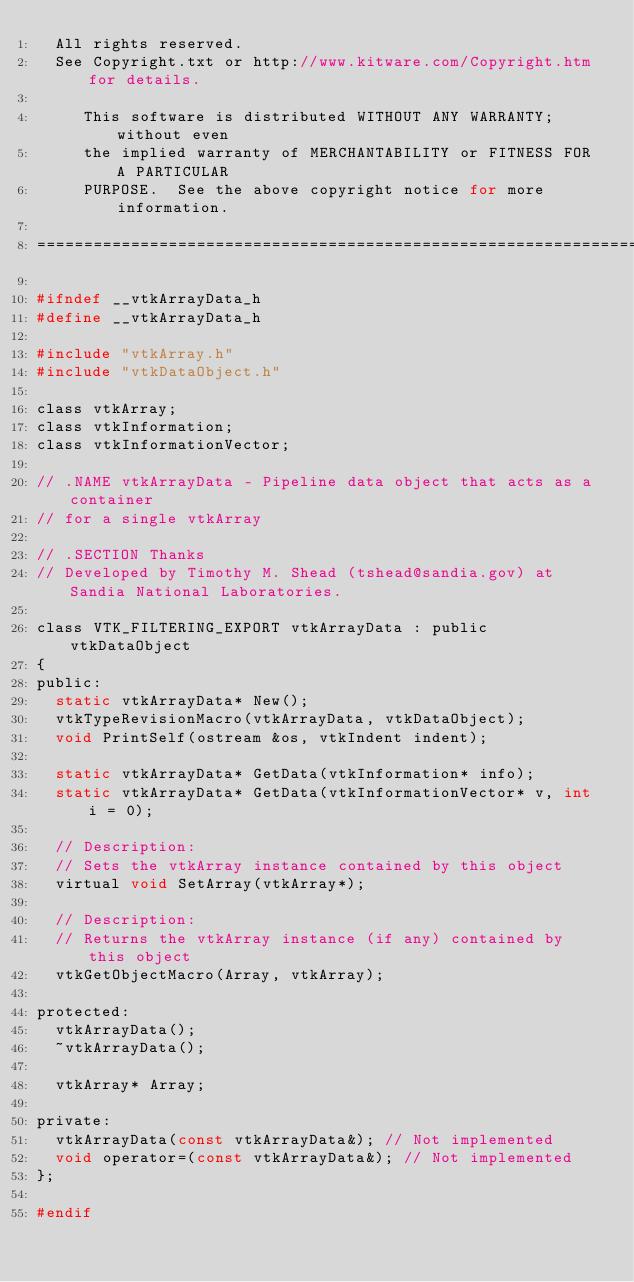Convert code to text. <code><loc_0><loc_0><loc_500><loc_500><_C_>  All rights reserved.
  See Copyright.txt or http://www.kitware.com/Copyright.htm for details.

     This software is distributed WITHOUT ANY WARRANTY; without even
     the implied warranty of MERCHANTABILITY or FITNESS FOR A PARTICULAR
     PURPOSE.  See the above copyright notice for more information.

=========================================================================*/

#ifndef __vtkArrayData_h
#define __vtkArrayData_h

#include "vtkArray.h"
#include "vtkDataObject.h"

class vtkArray;
class vtkInformation;
class vtkInformationVector;

// .NAME vtkArrayData - Pipeline data object that acts as a container
// for a single vtkArray

// .SECTION Thanks
// Developed by Timothy M. Shead (tshead@sandia.gov) at Sandia National Laboratories.

class VTK_FILTERING_EXPORT vtkArrayData : public vtkDataObject
{
public:
  static vtkArrayData* New();
  vtkTypeRevisionMacro(vtkArrayData, vtkDataObject);
  void PrintSelf(ostream &os, vtkIndent indent);

  static vtkArrayData* GetData(vtkInformation* info);
  static vtkArrayData* GetData(vtkInformationVector* v, int i = 0);

  // Description:
  // Sets the vtkArray instance contained by this object
  virtual void SetArray(vtkArray*);
  
  // Description:
  // Returns the vtkArray instance (if any) contained by this object
  vtkGetObjectMacro(Array, vtkArray);

protected:
  vtkArrayData();
  ~vtkArrayData();

  vtkArray* Array;

private:
  vtkArrayData(const vtkArrayData&); // Not implemented
  void operator=(const vtkArrayData&); // Not implemented
};

#endif

</code> 